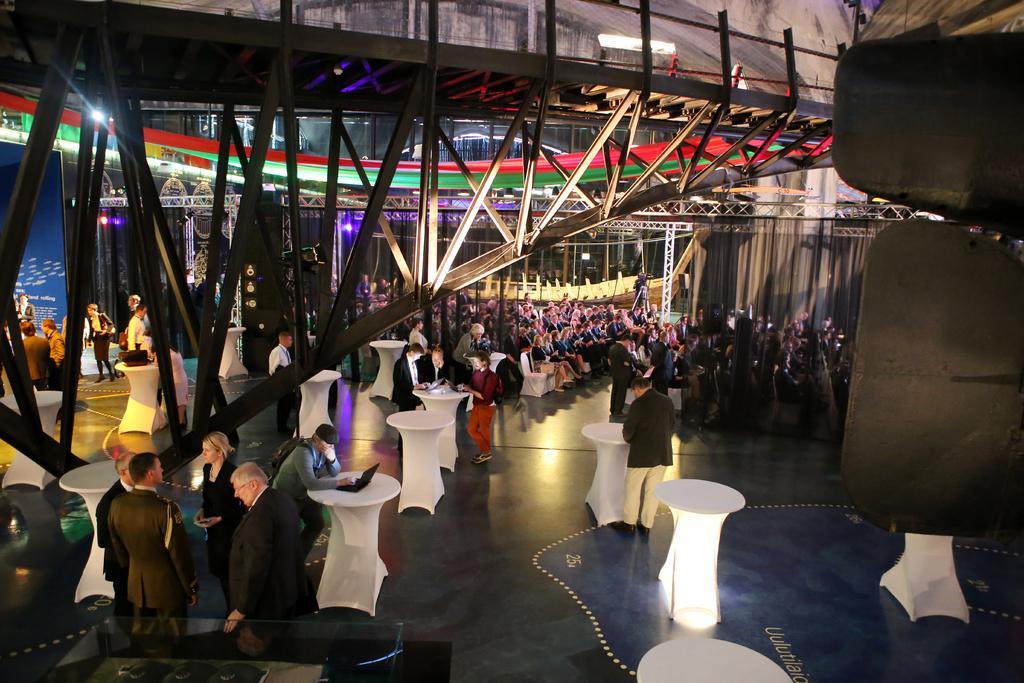Could you give a brief overview of what you see in this image? In this picture we can see all the persons sitting on chairs. we can see few persons standing near to the tables. At the top we can see shed. This is a floor. this is a cloth curtain in blue color. these are lights at the top. 